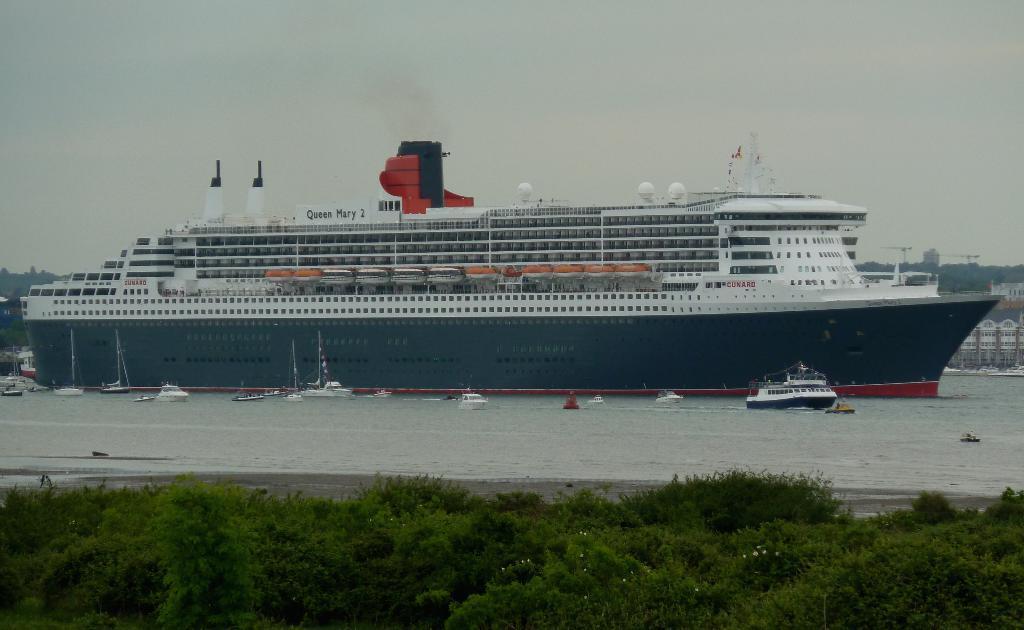Could you give a brief overview of what you see in this image? In this image there is a ship on the sea, in front there are plants. 